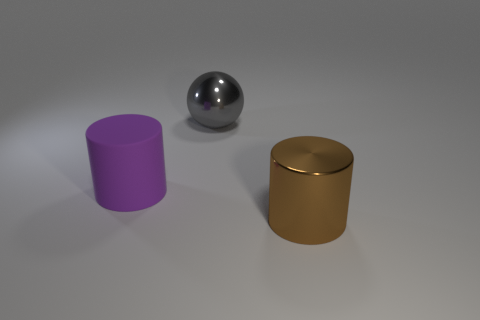Add 1 big gray metal objects. How many objects exist? 4 Subtract all large purple cylinders. Subtract all big brown balls. How many objects are left? 2 Add 1 large purple matte objects. How many large purple matte objects are left? 2 Add 1 big brown metallic cylinders. How many big brown metallic cylinders exist? 2 Subtract 0 blue spheres. How many objects are left? 3 Subtract all spheres. How many objects are left? 2 